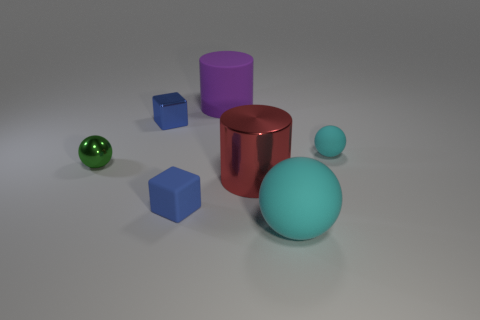There is a cylinder in front of the large cylinder behind the tiny green metallic sphere; what size is it?
Make the answer very short. Large. There is a big object that is the same color as the small rubber ball; what is its shape?
Make the answer very short. Sphere. What number of blocks are either purple rubber objects or small cyan objects?
Keep it short and to the point. 0. There is a blue metal thing; does it have the same size as the metallic thing right of the purple object?
Keep it short and to the point. No. Is the number of balls behind the small green shiny ball greater than the number of yellow spheres?
Your response must be concise. Yes. The blue block that is the same material as the small green object is what size?
Your answer should be very brief. Small. Is there a object of the same color as the small matte block?
Your answer should be compact. Yes. What number of objects are tiny yellow metal spheres or small things that are to the left of the matte cube?
Give a very brief answer. 2. Is the number of large objects greater than the number of objects?
Make the answer very short. No. The metal object that is the same color as the matte block is what size?
Your answer should be compact. Small. 